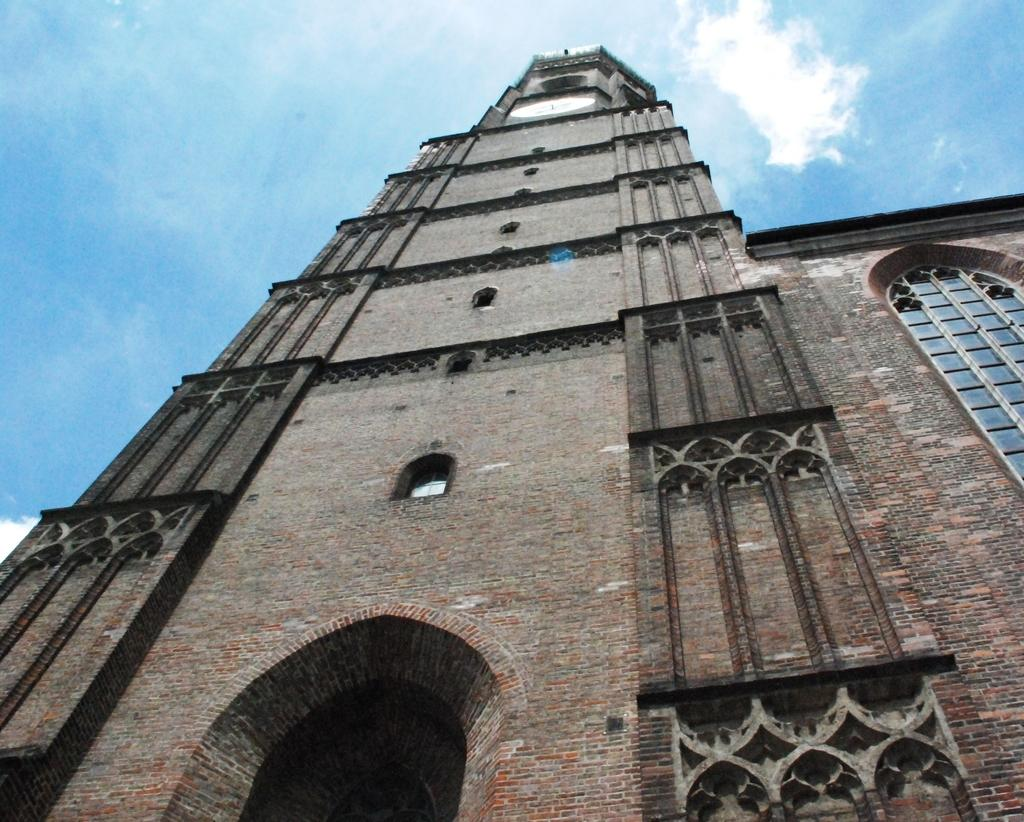What structure is located at the bottom of the image? There is a building at the bottom of the image. Where is the window located in the image? The window is on the right side of the image. What is visible at the top of the image? The sky is visible at the top of the image. What can be seen in the sky? Clouds are present in the sky. What type of discussion is taking place in the image? There is no discussion present in the image; it features a building, a window, the sky, and clouds. Can you describe the division of the building in the image? There is no division of the building mentioned in the image; it is a single structure. 